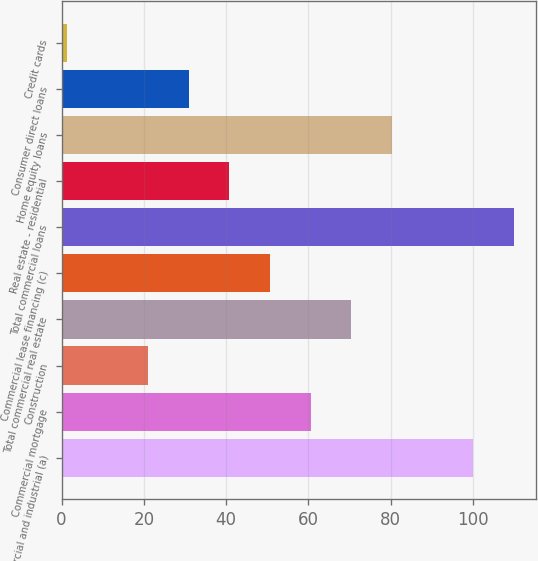Convert chart to OTSL. <chart><loc_0><loc_0><loc_500><loc_500><bar_chart><fcel>Commercial and industrial (a)<fcel>Commercial mortgage<fcel>Construction<fcel>Total commercial real estate<fcel>Commercial lease financing (c)<fcel>Total commercial loans<fcel>Real estate - residential<fcel>Home equity loans<fcel>Consumer direct loans<fcel>Credit cards<nl><fcel>100<fcel>60.52<fcel>21.04<fcel>70.39<fcel>50.65<fcel>109.87<fcel>40.78<fcel>80.26<fcel>30.91<fcel>1.3<nl></chart> 